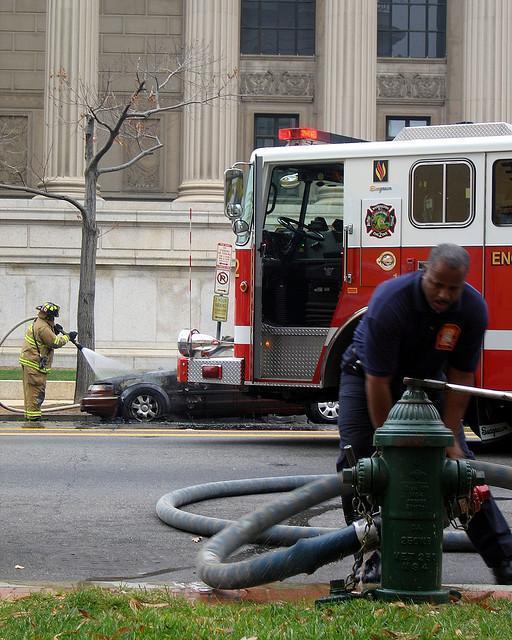How many people can you see?
Give a very brief answer. 2. How many cars have zebra stripes?
Give a very brief answer. 0. 